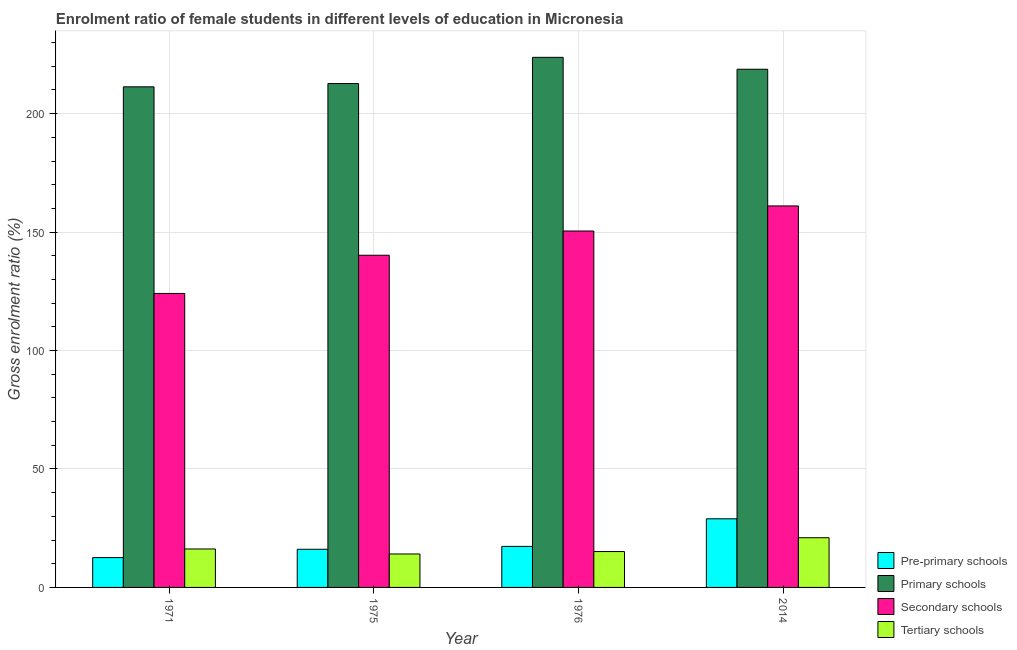How many different coloured bars are there?
Offer a very short reply. 4. How many groups of bars are there?
Your answer should be very brief. 4. Are the number of bars per tick equal to the number of legend labels?
Provide a succinct answer. Yes. Are the number of bars on each tick of the X-axis equal?
Your answer should be very brief. Yes. How many bars are there on the 1st tick from the right?
Your answer should be very brief. 4. What is the label of the 2nd group of bars from the left?
Give a very brief answer. 1975. What is the gross enrolment ratio(male) in pre-primary schools in 1975?
Offer a very short reply. 16.11. Across all years, what is the maximum gross enrolment ratio(male) in primary schools?
Ensure brevity in your answer.  223.78. Across all years, what is the minimum gross enrolment ratio(male) in pre-primary schools?
Give a very brief answer. 12.6. In which year was the gross enrolment ratio(male) in secondary schools maximum?
Provide a short and direct response. 2014. What is the total gross enrolment ratio(male) in secondary schools in the graph?
Keep it short and to the point. 575.86. What is the difference between the gross enrolment ratio(male) in secondary schools in 1971 and that in 1975?
Offer a very short reply. -16.12. What is the difference between the gross enrolment ratio(male) in tertiary schools in 2014 and the gross enrolment ratio(male) in primary schools in 1976?
Your answer should be compact. 5.83. What is the average gross enrolment ratio(male) in primary schools per year?
Your response must be concise. 216.65. What is the ratio of the gross enrolment ratio(male) in primary schools in 1971 to that in 1976?
Your answer should be very brief. 0.94. Is the difference between the gross enrolment ratio(male) in tertiary schools in 1971 and 2014 greater than the difference between the gross enrolment ratio(male) in pre-primary schools in 1971 and 2014?
Your answer should be very brief. No. What is the difference between the highest and the second highest gross enrolment ratio(male) in tertiary schools?
Provide a succinct answer. 4.75. What is the difference between the highest and the lowest gross enrolment ratio(male) in pre-primary schools?
Provide a succinct answer. 16.37. What does the 2nd bar from the left in 1975 represents?
Offer a very short reply. Primary schools. What does the 4th bar from the right in 2014 represents?
Provide a succinct answer. Pre-primary schools. How many bars are there?
Provide a short and direct response. 16. What is the difference between two consecutive major ticks on the Y-axis?
Provide a short and direct response. 50. Are the values on the major ticks of Y-axis written in scientific E-notation?
Provide a succinct answer. No. Does the graph contain grids?
Your answer should be very brief. Yes. What is the title of the graph?
Give a very brief answer. Enrolment ratio of female students in different levels of education in Micronesia. What is the label or title of the Y-axis?
Keep it short and to the point. Gross enrolment ratio (%). What is the Gross enrolment ratio (%) in Pre-primary schools in 1971?
Your response must be concise. 12.6. What is the Gross enrolment ratio (%) in Primary schools in 1971?
Provide a succinct answer. 211.34. What is the Gross enrolment ratio (%) of Secondary schools in 1971?
Make the answer very short. 124.11. What is the Gross enrolment ratio (%) of Tertiary schools in 1971?
Make the answer very short. 16.23. What is the Gross enrolment ratio (%) of Pre-primary schools in 1975?
Make the answer very short. 16.11. What is the Gross enrolment ratio (%) in Primary schools in 1975?
Your answer should be compact. 212.72. What is the Gross enrolment ratio (%) in Secondary schools in 1975?
Your response must be concise. 140.23. What is the Gross enrolment ratio (%) in Tertiary schools in 1975?
Your answer should be very brief. 14.12. What is the Gross enrolment ratio (%) in Pre-primary schools in 1976?
Make the answer very short. 17.32. What is the Gross enrolment ratio (%) in Primary schools in 1976?
Offer a very short reply. 223.78. What is the Gross enrolment ratio (%) of Secondary schools in 1976?
Give a very brief answer. 150.47. What is the Gross enrolment ratio (%) in Tertiary schools in 1976?
Your answer should be very brief. 15.14. What is the Gross enrolment ratio (%) of Pre-primary schools in 2014?
Offer a terse response. 28.97. What is the Gross enrolment ratio (%) in Primary schools in 2014?
Your response must be concise. 218.75. What is the Gross enrolment ratio (%) in Secondary schools in 2014?
Give a very brief answer. 161.05. What is the Gross enrolment ratio (%) in Tertiary schools in 2014?
Provide a short and direct response. 20.98. Across all years, what is the maximum Gross enrolment ratio (%) of Pre-primary schools?
Offer a terse response. 28.97. Across all years, what is the maximum Gross enrolment ratio (%) in Primary schools?
Ensure brevity in your answer.  223.78. Across all years, what is the maximum Gross enrolment ratio (%) of Secondary schools?
Provide a short and direct response. 161.05. Across all years, what is the maximum Gross enrolment ratio (%) of Tertiary schools?
Provide a succinct answer. 20.98. Across all years, what is the minimum Gross enrolment ratio (%) of Pre-primary schools?
Your response must be concise. 12.6. Across all years, what is the minimum Gross enrolment ratio (%) of Primary schools?
Provide a succinct answer. 211.34. Across all years, what is the minimum Gross enrolment ratio (%) of Secondary schools?
Offer a terse response. 124.11. Across all years, what is the minimum Gross enrolment ratio (%) in Tertiary schools?
Offer a terse response. 14.12. What is the total Gross enrolment ratio (%) of Pre-primary schools in the graph?
Your response must be concise. 74.99. What is the total Gross enrolment ratio (%) in Primary schools in the graph?
Offer a terse response. 866.59. What is the total Gross enrolment ratio (%) of Secondary schools in the graph?
Your answer should be compact. 575.86. What is the total Gross enrolment ratio (%) in Tertiary schools in the graph?
Your response must be concise. 66.47. What is the difference between the Gross enrolment ratio (%) of Pre-primary schools in 1971 and that in 1975?
Your answer should be very brief. -3.51. What is the difference between the Gross enrolment ratio (%) in Primary schools in 1971 and that in 1975?
Make the answer very short. -1.38. What is the difference between the Gross enrolment ratio (%) of Secondary schools in 1971 and that in 1975?
Ensure brevity in your answer.  -16.12. What is the difference between the Gross enrolment ratio (%) in Tertiary schools in 1971 and that in 1975?
Ensure brevity in your answer.  2.11. What is the difference between the Gross enrolment ratio (%) in Pre-primary schools in 1971 and that in 1976?
Offer a terse response. -4.72. What is the difference between the Gross enrolment ratio (%) of Primary schools in 1971 and that in 1976?
Provide a succinct answer. -12.45. What is the difference between the Gross enrolment ratio (%) in Secondary schools in 1971 and that in 1976?
Your answer should be very brief. -26.36. What is the difference between the Gross enrolment ratio (%) of Tertiary schools in 1971 and that in 1976?
Offer a very short reply. 1.09. What is the difference between the Gross enrolment ratio (%) in Pre-primary schools in 1971 and that in 2014?
Provide a succinct answer. -16.37. What is the difference between the Gross enrolment ratio (%) in Primary schools in 1971 and that in 2014?
Offer a terse response. -7.42. What is the difference between the Gross enrolment ratio (%) of Secondary schools in 1971 and that in 2014?
Keep it short and to the point. -36.95. What is the difference between the Gross enrolment ratio (%) in Tertiary schools in 1971 and that in 2014?
Provide a succinct answer. -4.75. What is the difference between the Gross enrolment ratio (%) in Pre-primary schools in 1975 and that in 1976?
Keep it short and to the point. -1.21. What is the difference between the Gross enrolment ratio (%) of Primary schools in 1975 and that in 1976?
Provide a short and direct response. -11.07. What is the difference between the Gross enrolment ratio (%) of Secondary schools in 1975 and that in 1976?
Provide a succinct answer. -10.24. What is the difference between the Gross enrolment ratio (%) of Tertiary schools in 1975 and that in 1976?
Offer a terse response. -1.03. What is the difference between the Gross enrolment ratio (%) in Pre-primary schools in 1975 and that in 2014?
Your answer should be very brief. -12.86. What is the difference between the Gross enrolment ratio (%) in Primary schools in 1975 and that in 2014?
Offer a terse response. -6.03. What is the difference between the Gross enrolment ratio (%) of Secondary schools in 1975 and that in 2014?
Offer a very short reply. -20.82. What is the difference between the Gross enrolment ratio (%) of Tertiary schools in 1975 and that in 2014?
Give a very brief answer. -6.86. What is the difference between the Gross enrolment ratio (%) in Pre-primary schools in 1976 and that in 2014?
Your answer should be very brief. -11.65. What is the difference between the Gross enrolment ratio (%) in Primary schools in 1976 and that in 2014?
Your answer should be very brief. 5.03. What is the difference between the Gross enrolment ratio (%) in Secondary schools in 1976 and that in 2014?
Your answer should be very brief. -10.59. What is the difference between the Gross enrolment ratio (%) in Tertiary schools in 1976 and that in 2014?
Your answer should be compact. -5.83. What is the difference between the Gross enrolment ratio (%) in Pre-primary schools in 1971 and the Gross enrolment ratio (%) in Primary schools in 1975?
Provide a short and direct response. -200.12. What is the difference between the Gross enrolment ratio (%) of Pre-primary schools in 1971 and the Gross enrolment ratio (%) of Secondary schools in 1975?
Offer a terse response. -127.63. What is the difference between the Gross enrolment ratio (%) in Pre-primary schools in 1971 and the Gross enrolment ratio (%) in Tertiary schools in 1975?
Provide a succinct answer. -1.52. What is the difference between the Gross enrolment ratio (%) in Primary schools in 1971 and the Gross enrolment ratio (%) in Secondary schools in 1975?
Offer a very short reply. 71.11. What is the difference between the Gross enrolment ratio (%) of Primary schools in 1971 and the Gross enrolment ratio (%) of Tertiary schools in 1975?
Ensure brevity in your answer.  197.22. What is the difference between the Gross enrolment ratio (%) in Secondary schools in 1971 and the Gross enrolment ratio (%) in Tertiary schools in 1975?
Keep it short and to the point. 109.99. What is the difference between the Gross enrolment ratio (%) in Pre-primary schools in 1971 and the Gross enrolment ratio (%) in Primary schools in 1976?
Offer a terse response. -211.19. What is the difference between the Gross enrolment ratio (%) in Pre-primary schools in 1971 and the Gross enrolment ratio (%) in Secondary schools in 1976?
Keep it short and to the point. -137.87. What is the difference between the Gross enrolment ratio (%) in Pre-primary schools in 1971 and the Gross enrolment ratio (%) in Tertiary schools in 1976?
Your answer should be very brief. -2.55. What is the difference between the Gross enrolment ratio (%) in Primary schools in 1971 and the Gross enrolment ratio (%) in Secondary schools in 1976?
Offer a very short reply. 60.87. What is the difference between the Gross enrolment ratio (%) in Primary schools in 1971 and the Gross enrolment ratio (%) in Tertiary schools in 1976?
Ensure brevity in your answer.  196.19. What is the difference between the Gross enrolment ratio (%) of Secondary schools in 1971 and the Gross enrolment ratio (%) of Tertiary schools in 1976?
Your response must be concise. 108.96. What is the difference between the Gross enrolment ratio (%) in Pre-primary schools in 1971 and the Gross enrolment ratio (%) in Primary schools in 2014?
Give a very brief answer. -206.15. What is the difference between the Gross enrolment ratio (%) of Pre-primary schools in 1971 and the Gross enrolment ratio (%) of Secondary schools in 2014?
Make the answer very short. -148.46. What is the difference between the Gross enrolment ratio (%) in Pre-primary schools in 1971 and the Gross enrolment ratio (%) in Tertiary schools in 2014?
Give a very brief answer. -8.38. What is the difference between the Gross enrolment ratio (%) of Primary schools in 1971 and the Gross enrolment ratio (%) of Secondary schools in 2014?
Provide a short and direct response. 50.28. What is the difference between the Gross enrolment ratio (%) of Primary schools in 1971 and the Gross enrolment ratio (%) of Tertiary schools in 2014?
Offer a terse response. 190.36. What is the difference between the Gross enrolment ratio (%) in Secondary schools in 1971 and the Gross enrolment ratio (%) in Tertiary schools in 2014?
Offer a very short reply. 103.13. What is the difference between the Gross enrolment ratio (%) in Pre-primary schools in 1975 and the Gross enrolment ratio (%) in Primary schools in 1976?
Your answer should be very brief. -207.68. What is the difference between the Gross enrolment ratio (%) of Pre-primary schools in 1975 and the Gross enrolment ratio (%) of Secondary schools in 1976?
Keep it short and to the point. -134.36. What is the difference between the Gross enrolment ratio (%) of Pre-primary schools in 1975 and the Gross enrolment ratio (%) of Tertiary schools in 1976?
Provide a short and direct response. 0.96. What is the difference between the Gross enrolment ratio (%) in Primary schools in 1975 and the Gross enrolment ratio (%) in Secondary schools in 1976?
Keep it short and to the point. 62.25. What is the difference between the Gross enrolment ratio (%) of Primary schools in 1975 and the Gross enrolment ratio (%) of Tertiary schools in 1976?
Offer a very short reply. 197.57. What is the difference between the Gross enrolment ratio (%) of Secondary schools in 1975 and the Gross enrolment ratio (%) of Tertiary schools in 1976?
Make the answer very short. 125.09. What is the difference between the Gross enrolment ratio (%) of Pre-primary schools in 1975 and the Gross enrolment ratio (%) of Primary schools in 2014?
Provide a short and direct response. -202.65. What is the difference between the Gross enrolment ratio (%) of Pre-primary schools in 1975 and the Gross enrolment ratio (%) of Secondary schools in 2014?
Your answer should be compact. -144.95. What is the difference between the Gross enrolment ratio (%) of Pre-primary schools in 1975 and the Gross enrolment ratio (%) of Tertiary schools in 2014?
Provide a succinct answer. -4.87. What is the difference between the Gross enrolment ratio (%) of Primary schools in 1975 and the Gross enrolment ratio (%) of Secondary schools in 2014?
Provide a succinct answer. 51.66. What is the difference between the Gross enrolment ratio (%) of Primary schools in 1975 and the Gross enrolment ratio (%) of Tertiary schools in 2014?
Give a very brief answer. 191.74. What is the difference between the Gross enrolment ratio (%) in Secondary schools in 1975 and the Gross enrolment ratio (%) in Tertiary schools in 2014?
Your answer should be very brief. 119.25. What is the difference between the Gross enrolment ratio (%) in Pre-primary schools in 1976 and the Gross enrolment ratio (%) in Primary schools in 2014?
Ensure brevity in your answer.  -201.43. What is the difference between the Gross enrolment ratio (%) in Pre-primary schools in 1976 and the Gross enrolment ratio (%) in Secondary schools in 2014?
Give a very brief answer. -143.73. What is the difference between the Gross enrolment ratio (%) in Pre-primary schools in 1976 and the Gross enrolment ratio (%) in Tertiary schools in 2014?
Your response must be concise. -3.66. What is the difference between the Gross enrolment ratio (%) in Primary schools in 1976 and the Gross enrolment ratio (%) in Secondary schools in 2014?
Your answer should be compact. 62.73. What is the difference between the Gross enrolment ratio (%) of Primary schools in 1976 and the Gross enrolment ratio (%) of Tertiary schools in 2014?
Your response must be concise. 202.8. What is the difference between the Gross enrolment ratio (%) in Secondary schools in 1976 and the Gross enrolment ratio (%) in Tertiary schools in 2014?
Offer a terse response. 129.49. What is the average Gross enrolment ratio (%) of Pre-primary schools per year?
Keep it short and to the point. 18.75. What is the average Gross enrolment ratio (%) of Primary schools per year?
Your response must be concise. 216.65. What is the average Gross enrolment ratio (%) of Secondary schools per year?
Provide a succinct answer. 143.96. What is the average Gross enrolment ratio (%) in Tertiary schools per year?
Keep it short and to the point. 16.62. In the year 1971, what is the difference between the Gross enrolment ratio (%) in Pre-primary schools and Gross enrolment ratio (%) in Primary schools?
Provide a succinct answer. -198.74. In the year 1971, what is the difference between the Gross enrolment ratio (%) of Pre-primary schools and Gross enrolment ratio (%) of Secondary schools?
Offer a very short reply. -111.51. In the year 1971, what is the difference between the Gross enrolment ratio (%) in Pre-primary schools and Gross enrolment ratio (%) in Tertiary schools?
Give a very brief answer. -3.63. In the year 1971, what is the difference between the Gross enrolment ratio (%) of Primary schools and Gross enrolment ratio (%) of Secondary schools?
Your response must be concise. 87.23. In the year 1971, what is the difference between the Gross enrolment ratio (%) in Primary schools and Gross enrolment ratio (%) in Tertiary schools?
Give a very brief answer. 195.11. In the year 1971, what is the difference between the Gross enrolment ratio (%) of Secondary schools and Gross enrolment ratio (%) of Tertiary schools?
Your response must be concise. 107.88. In the year 1975, what is the difference between the Gross enrolment ratio (%) in Pre-primary schools and Gross enrolment ratio (%) in Primary schools?
Your answer should be compact. -196.61. In the year 1975, what is the difference between the Gross enrolment ratio (%) of Pre-primary schools and Gross enrolment ratio (%) of Secondary schools?
Keep it short and to the point. -124.12. In the year 1975, what is the difference between the Gross enrolment ratio (%) in Pre-primary schools and Gross enrolment ratio (%) in Tertiary schools?
Your response must be concise. 1.99. In the year 1975, what is the difference between the Gross enrolment ratio (%) of Primary schools and Gross enrolment ratio (%) of Secondary schools?
Your answer should be very brief. 72.49. In the year 1975, what is the difference between the Gross enrolment ratio (%) of Primary schools and Gross enrolment ratio (%) of Tertiary schools?
Keep it short and to the point. 198.6. In the year 1975, what is the difference between the Gross enrolment ratio (%) in Secondary schools and Gross enrolment ratio (%) in Tertiary schools?
Offer a very short reply. 126.11. In the year 1976, what is the difference between the Gross enrolment ratio (%) in Pre-primary schools and Gross enrolment ratio (%) in Primary schools?
Ensure brevity in your answer.  -206.46. In the year 1976, what is the difference between the Gross enrolment ratio (%) of Pre-primary schools and Gross enrolment ratio (%) of Secondary schools?
Your answer should be very brief. -133.15. In the year 1976, what is the difference between the Gross enrolment ratio (%) in Pre-primary schools and Gross enrolment ratio (%) in Tertiary schools?
Keep it short and to the point. 2.18. In the year 1976, what is the difference between the Gross enrolment ratio (%) in Primary schools and Gross enrolment ratio (%) in Secondary schools?
Your response must be concise. 73.32. In the year 1976, what is the difference between the Gross enrolment ratio (%) of Primary schools and Gross enrolment ratio (%) of Tertiary schools?
Make the answer very short. 208.64. In the year 1976, what is the difference between the Gross enrolment ratio (%) of Secondary schools and Gross enrolment ratio (%) of Tertiary schools?
Your response must be concise. 135.32. In the year 2014, what is the difference between the Gross enrolment ratio (%) of Pre-primary schools and Gross enrolment ratio (%) of Primary schools?
Keep it short and to the point. -189.78. In the year 2014, what is the difference between the Gross enrolment ratio (%) in Pre-primary schools and Gross enrolment ratio (%) in Secondary schools?
Offer a terse response. -132.08. In the year 2014, what is the difference between the Gross enrolment ratio (%) of Pre-primary schools and Gross enrolment ratio (%) of Tertiary schools?
Your response must be concise. 7.99. In the year 2014, what is the difference between the Gross enrolment ratio (%) in Primary schools and Gross enrolment ratio (%) in Secondary schools?
Your answer should be compact. 57.7. In the year 2014, what is the difference between the Gross enrolment ratio (%) of Primary schools and Gross enrolment ratio (%) of Tertiary schools?
Provide a short and direct response. 197.77. In the year 2014, what is the difference between the Gross enrolment ratio (%) in Secondary schools and Gross enrolment ratio (%) in Tertiary schools?
Ensure brevity in your answer.  140.07. What is the ratio of the Gross enrolment ratio (%) in Pre-primary schools in 1971 to that in 1975?
Provide a short and direct response. 0.78. What is the ratio of the Gross enrolment ratio (%) in Primary schools in 1971 to that in 1975?
Make the answer very short. 0.99. What is the ratio of the Gross enrolment ratio (%) of Secondary schools in 1971 to that in 1975?
Provide a succinct answer. 0.89. What is the ratio of the Gross enrolment ratio (%) of Tertiary schools in 1971 to that in 1975?
Your answer should be compact. 1.15. What is the ratio of the Gross enrolment ratio (%) in Pre-primary schools in 1971 to that in 1976?
Your response must be concise. 0.73. What is the ratio of the Gross enrolment ratio (%) in Secondary schools in 1971 to that in 1976?
Your response must be concise. 0.82. What is the ratio of the Gross enrolment ratio (%) of Tertiary schools in 1971 to that in 1976?
Provide a succinct answer. 1.07. What is the ratio of the Gross enrolment ratio (%) in Pre-primary schools in 1971 to that in 2014?
Ensure brevity in your answer.  0.43. What is the ratio of the Gross enrolment ratio (%) in Primary schools in 1971 to that in 2014?
Offer a very short reply. 0.97. What is the ratio of the Gross enrolment ratio (%) of Secondary schools in 1971 to that in 2014?
Ensure brevity in your answer.  0.77. What is the ratio of the Gross enrolment ratio (%) in Tertiary schools in 1971 to that in 2014?
Keep it short and to the point. 0.77. What is the ratio of the Gross enrolment ratio (%) in Pre-primary schools in 1975 to that in 1976?
Give a very brief answer. 0.93. What is the ratio of the Gross enrolment ratio (%) in Primary schools in 1975 to that in 1976?
Offer a very short reply. 0.95. What is the ratio of the Gross enrolment ratio (%) in Secondary schools in 1975 to that in 1976?
Your response must be concise. 0.93. What is the ratio of the Gross enrolment ratio (%) of Tertiary schools in 1975 to that in 1976?
Make the answer very short. 0.93. What is the ratio of the Gross enrolment ratio (%) in Pre-primary schools in 1975 to that in 2014?
Give a very brief answer. 0.56. What is the ratio of the Gross enrolment ratio (%) of Primary schools in 1975 to that in 2014?
Provide a succinct answer. 0.97. What is the ratio of the Gross enrolment ratio (%) of Secondary schools in 1975 to that in 2014?
Offer a very short reply. 0.87. What is the ratio of the Gross enrolment ratio (%) in Tertiary schools in 1975 to that in 2014?
Provide a succinct answer. 0.67. What is the ratio of the Gross enrolment ratio (%) in Pre-primary schools in 1976 to that in 2014?
Your response must be concise. 0.6. What is the ratio of the Gross enrolment ratio (%) in Secondary schools in 1976 to that in 2014?
Your answer should be very brief. 0.93. What is the ratio of the Gross enrolment ratio (%) of Tertiary schools in 1976 to that in 2014?
Keep it short and to the point. 0.72. What is the difference between the highest and the second highest Gross enrolment ratio (%) of Pre-primary schools?
Keep it short and to the point. 11.65. What is the difference between the highest and the second highest Gross enrolment ratio (%) of Primary schools?
Your response must be concise. 5.03. What is the difference between the highest and the second highest Gross enrolment ratio (%) of Secondary schools?
Offer a very short reply. 10.59. What is the difference between the highest and the second highest Gross enrolment ratio (%) in Tertiary schools?
Your answer should be compact. 4.75. What is the difference between the highest and the lowest Gross enrolment ratio (%) in Pre-primary schools?
Provide a succinct answer. 16.37. What is the difference between the highest and the lowest Gross enrolment ratio (%) in Primary schools?
Ensure brevity in your answer.  12.45. What is the difference between the highest and the lowest Gross enrolment ratio (%) of Secondary schools?
Your answer should be very brief. 36.95. What is the difference between the highest and the lowest Gross enrolment ratio (%) of Tertiary schools?
Offer a terse response. 6.86. 